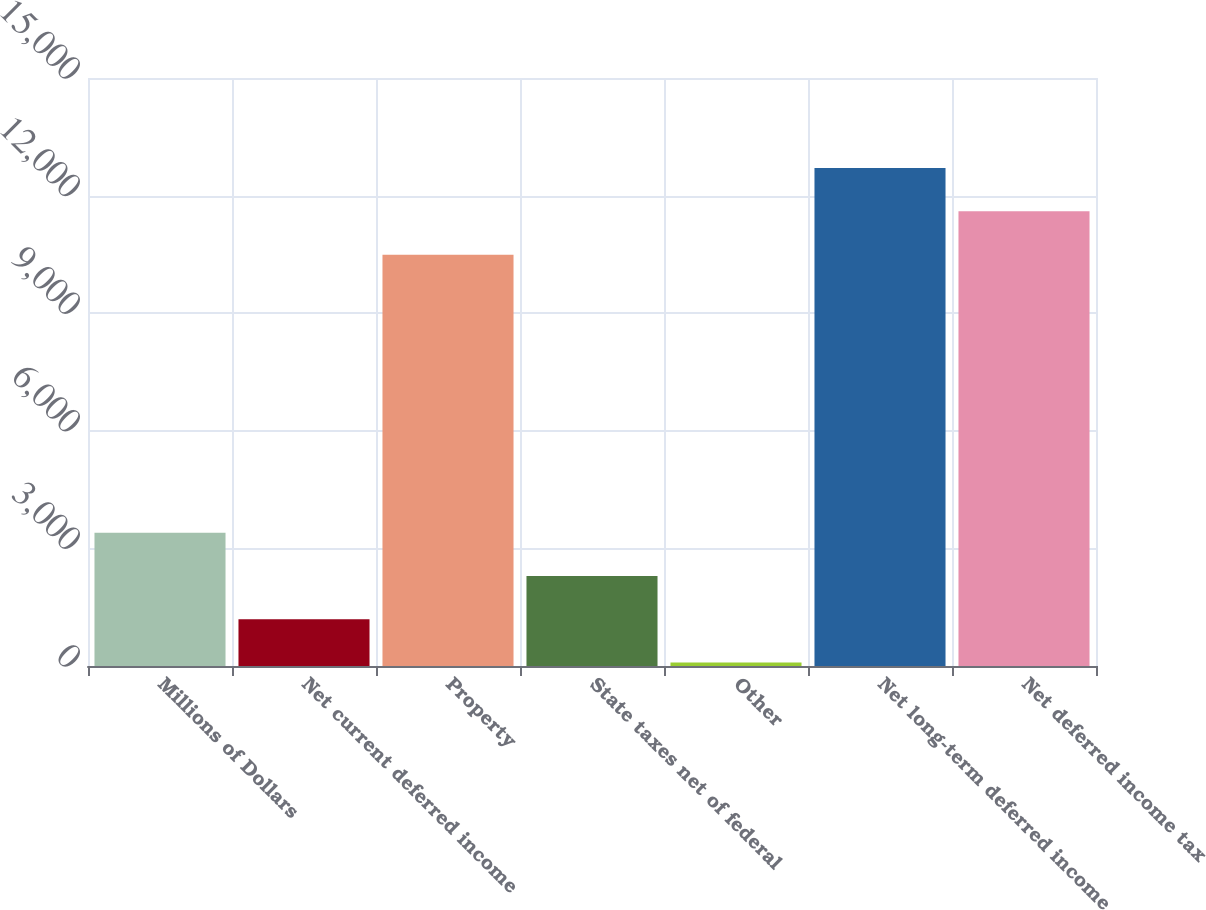Convert chart. <chart><loc_0><loc_0><loc_500><loc_500><bar_chart><fcel>Millions of Dollars<fcel>Net current deferred income<fcel>Property<fcel>State taxes net of federal<fcel>Other<fcel>Net long-term deferred income<fcel>Net deferred income tax<nl><fcel>3402<fcel>1194<fcel>10494<fcel>2298<fcel>90<fcel>12702<fcel>11598<nl></chart> 